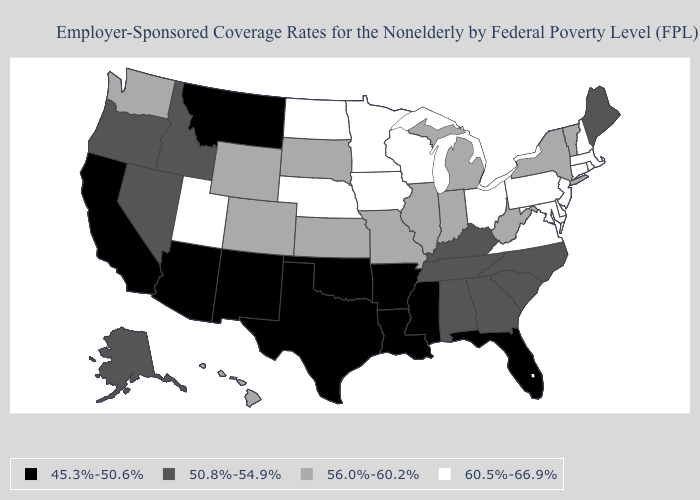What is the value of Indiana?
Keep it brief. 56.0%-60.2%. What is the lowest value in states that border Pennsylvania?
Write a very short answer. 56.0%-60.2%. What is the highest value in states that border North Carolina?
Write a very short answer. 60.5%-66.9%. What is the value of Louisiana?
Quick response, please. 45.3%-50.6%. Name the states that have a value in the range 56.0%-60.2%?
Answer briefly. Colorado, Hawaii, Illinois, Indiana, Kansas, Michigan, Missouri, New York, South Dakota, Vermont, Washington, West Virginia, Wyoming. Which states have the lowest value in the USA?
Quick response, please. Arizona, Arkansas, California, Florida, Louisiana, Mississippi, Montana, New Mexico, Oklahoma, Texas. What is the lowest value in states that border Tennessee?
Short answer required. 45.3%-50.6%. Is the legend a continuous bar?
Quick response, please. No. What is the highest value in the USA?
Answer briefly. 60.5%-66.9%. Name the states that have a value in the range 60.5%-66.9%?
Write a very short answer. Connecticut, Delaware, Iowa, Maryland, Massachusetts, Minnesota, Nebraska, New Hampshire, New Jersey, North Dakota, Ohio, Pennsylvania, Rhode Island, Utah, Virginia, Wisconsin. Among the states that border New Jersey , which have the lowest value?
Give a very brief answer. New York. What is the value of Virginia?
Answer briefly. 60.5%-66.9%. Which states hav the highest value in the West?
Keep it brief. Utah. 